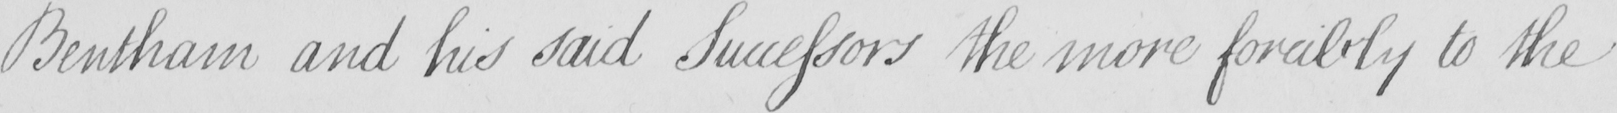Please provide the text content of this handwritten line. Bentham and his said Successors the more forcibly to the 